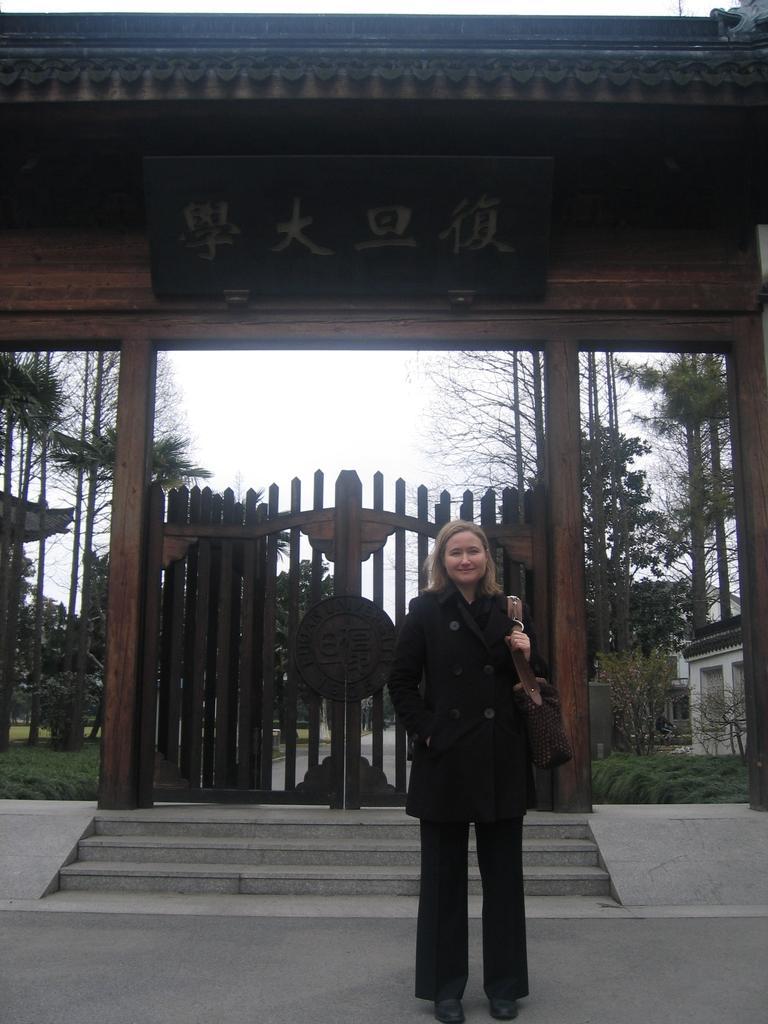Please provide a concise description of this image. In this image there is a woman standing on the ground. She is smiling. She is wearing a handbag. Behind her there is a gate. In front of the gate there are steps. Behind the gate there are trees and grass on the ground. To the right there is a house. Above the gate there is the sky. At the top there is a board to the wall. 